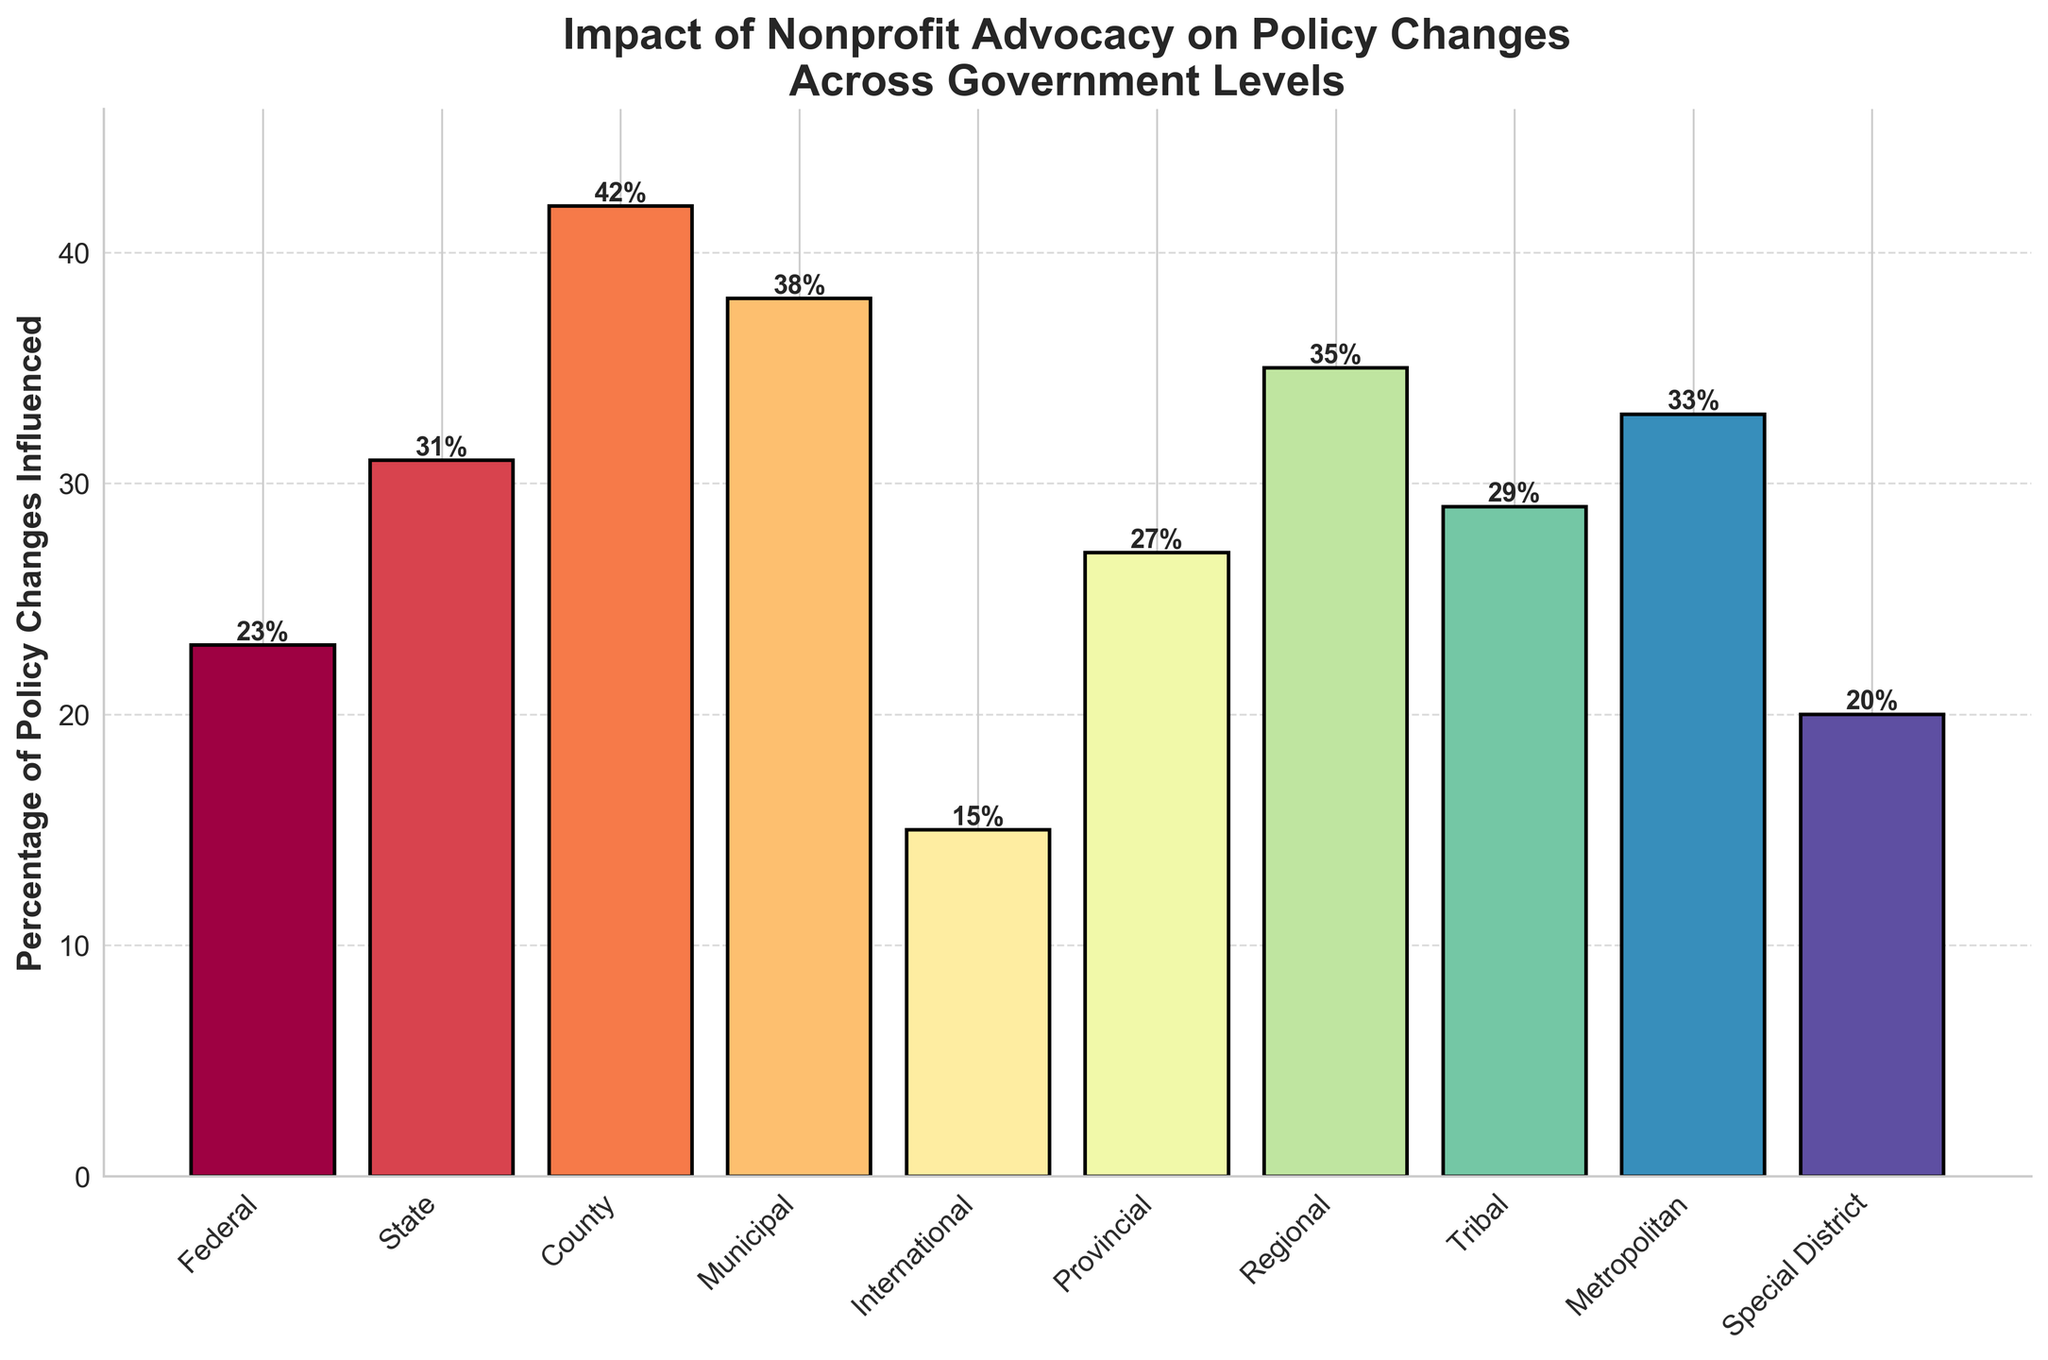What government level has the highest percentage of policy changes influenced by nonprofit advocacy efforts? The highest bar on the chart represents the government level with the highest percentage. Here, the County level has the highest percentage.
Answer: County What is the difference in the percentage of policy changes influenced between the Federal and State levels? To find the difference, subtract the Federal percentage from the State percentage: \(31\% - 23\%\).
Answer: 8% Which government level has a percentage close to 30%? Identify the bars labeled with percentages close to 30%. The State (31%), Provincial (27%), and Tribal (29%) levels are close.
Answer: State, Provincial, Tribal Is the percentage of policy changes influenced at the Municipal level greater than that at the Metropolitan level? Compare the heights or percentages of the Municipal (38%) and Metropolitan (33%) bars. The Municipal level is greater.
Answer: Yes What is the combined percentage of policy changes influenced at the County and Municipal levels? Add the percentages of the County and Municipal levels: \(42\% + 38\% = 80\%\).
Answer: 80% Which government level has the lowest percentage of policy changes influenced, and what is that percentage? The smallest bar represents the lowest percentage in the chart, which is the International level with 15%.
Answer: International, 15% Does any government level have an influence percentage exactly equal to 20%? Check the bars for a percentage exactly at 20%. The Special District level has 20%.
Answer: Special District How many government levels have a percentage of policy changes influenced of at least 30%? Count the bars with percentages 30% or higher: State (31%), County (42%), Municipal (38%), Regional (35%), and Metropolitan (33%). There are five levels.
Answer: 5 What is the average percentage of policy changes influenced for Provincial, Regional, and Tribal levels? Calculate the average by adding their percentages and dividing by the number of levels: \((27\% + 35\% + 29\%) / 3 = 30.33\%\).
Answer: 30.33% Compare the influence at the Federal and International levels. How much higher is the Federal influence percentage? Subtract the International percentage from the Federal percentage: \(23\% - 15\%\). The Federal influence is 8% higher.
Answer: 8% 